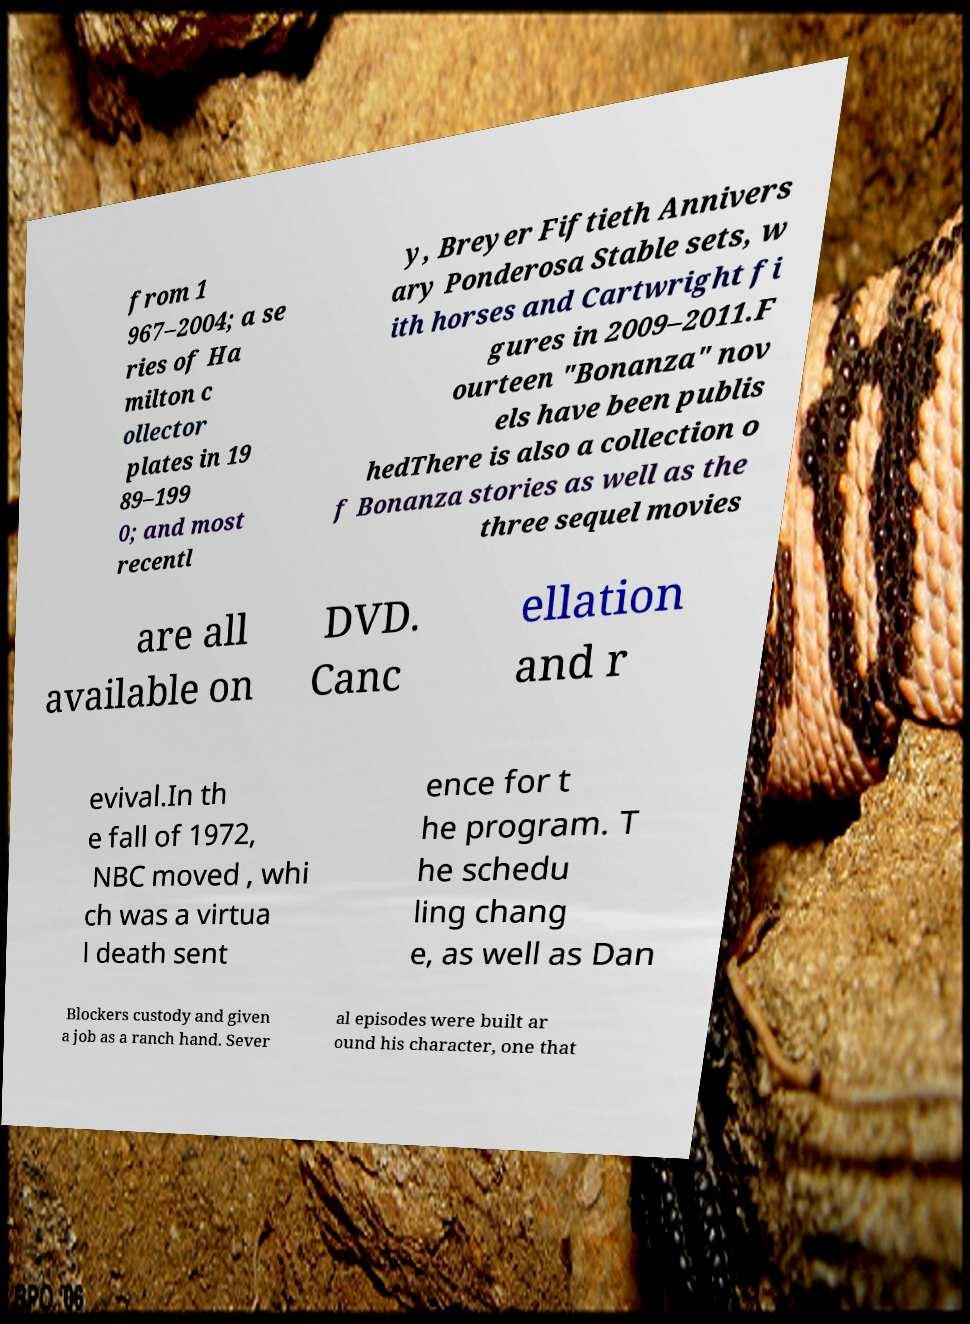What messages or text are displayed in this image? I need them in a readable, typed format. from 1 967–2004; a se ries of Ha milton c ollector plates in 19 89–199 0; and most recentl y, Breyer Fiftieth Annivers ary Ponderosa Stable sets, w ith horses and Cartwright fi gures in 2009–2011.F ourteen "Bonanza" nov els have been publis hedThere is also a collection o f Bonanza stories as well as the three sequel movies are all available on DVD. Canc ellation and r evival.In th e fall of 1972, NBC moved , whi ch was a virtua l death sent ence for t he program. T he schedu ling chang e, as well as Dan Blockers custody and given a job as a ranch hand. Sever al episodes were built ar ound his character, one that 